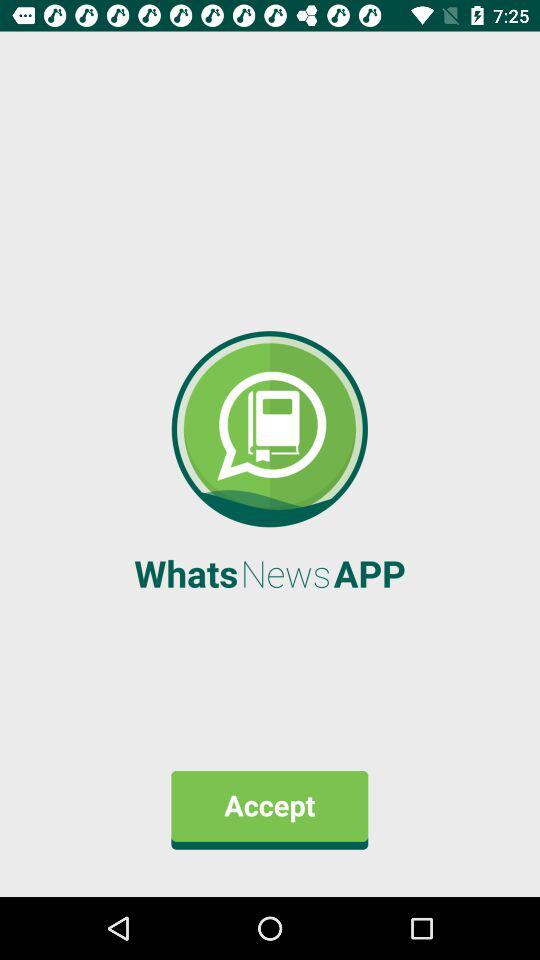What is the application name? The application name is "Whats News APP". 